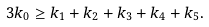<formula> <loc_0><loc_0><loc_500><loc_500>3 k _ { 0 } \geq k _ { 1 } + k _ { 2 } + k _ { 3 } + k _ { 4 } + k _ { 5 } .</formula> 